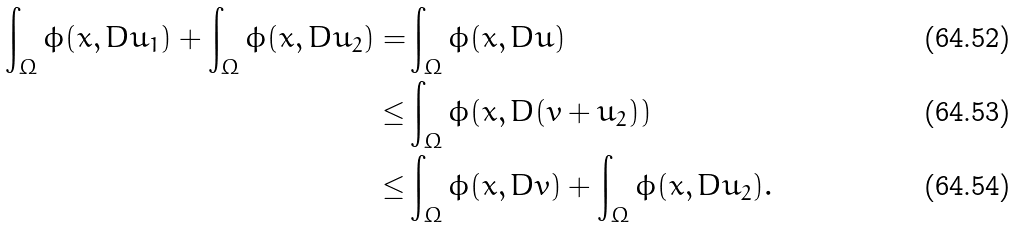<formula> <loc_0><loc_0><loc_500><loc_500>\int _ { \Omega } \phi ( x , D u _ { 1 } ) + \int _ { \Omega } \phi ( x , D u _ { 2 } ) = & \int _ { \Omega } \phi ( x , D u ) \\ \leq & \int _ { \Omega } \phi ( x , D ( v + u _ { 2 } ) ) \\ \leq & \int _ { \Omega } \phi ( x , D v ) + \int _ { \Omega } \phi ( x , D u _ { 2 } ) .</formula> 